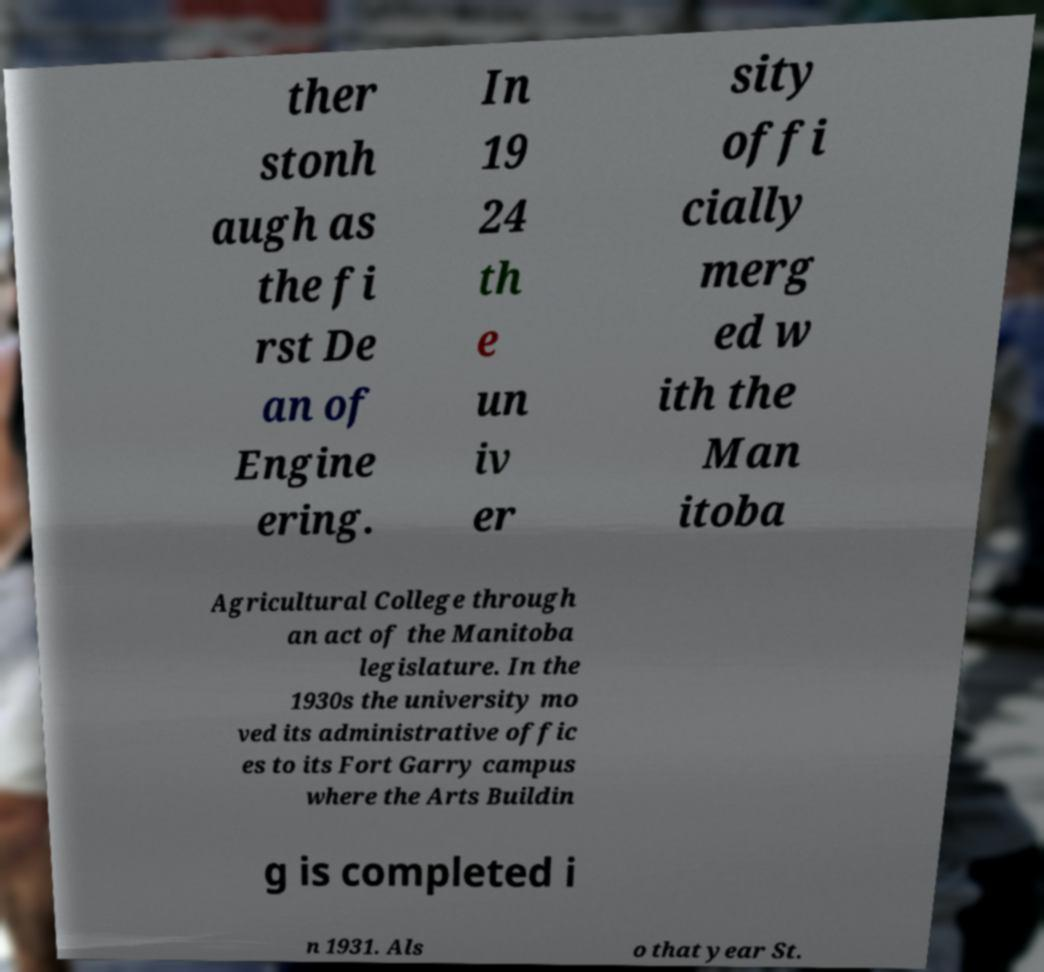For documentation purposes, I need the text within this image transcribed. Could you provide that? ther stonh augh as the fi rst De an of Engine ering. In 19 24 th e un iv er sity offi cially merg ed w ith the Man itoba Agricultural College through an act of the Manitoba legislature. In the 1930s the university mo ved its administrative offic es to its Fort Garry campus where the Arts Buildin g is completed i n 1931. Als o that year St. 